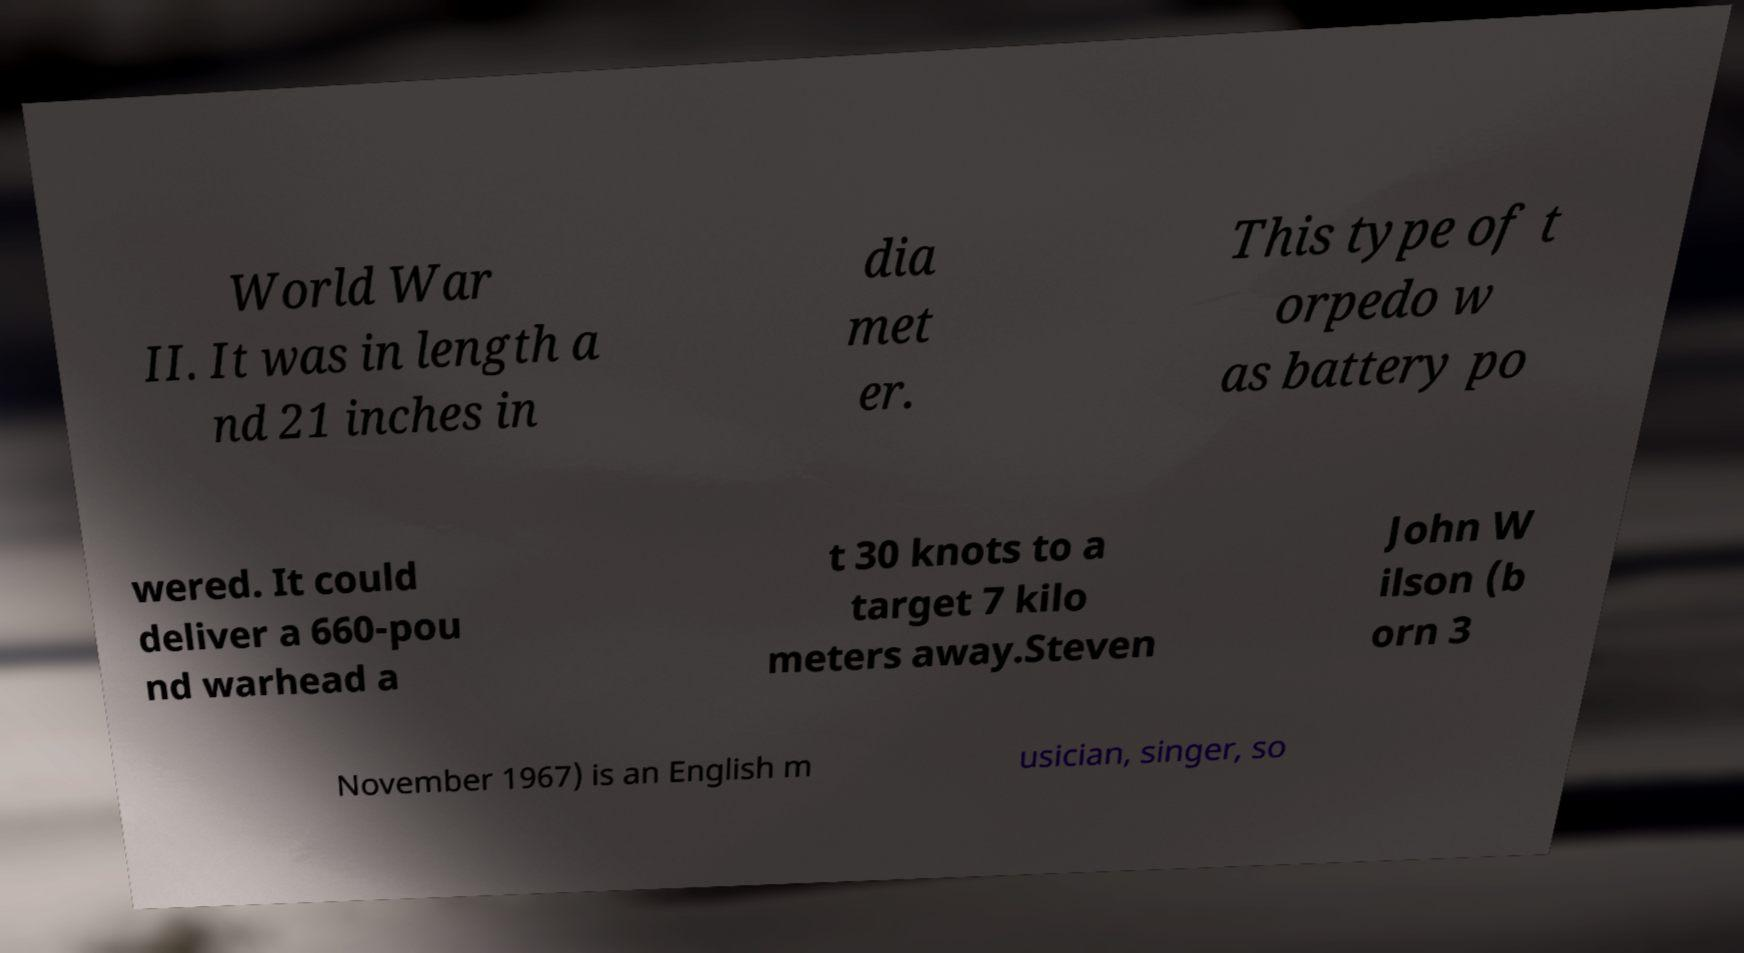Could you extract and type out the text from this image? World War II. It was in length a nd 21 inches in dia met er. This type of t orpedo w as battery po wered. It could deliver a 660-pou nd warhead a t 30 knots to a target 7 kilo meters away.Steven John W ilson (b orn 3 November 1967) is an English m usician, singer, so 